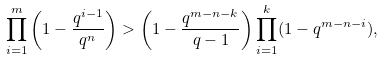<formula> <loc_0><loc_0><loc_500><loc_500>\prod _ { i = 1 } ^ { m } \left ( 1 - \frac { q ^ { i - 1 } } { q ^ { n } } \right ) > \left ( 1 - \frac { q ^ { m - n - k } } { q - 1 } \right ) \prod _ { i = 1 } ^ { k } ( 1 - q ^ { m - n - i } ) ,</formula> 